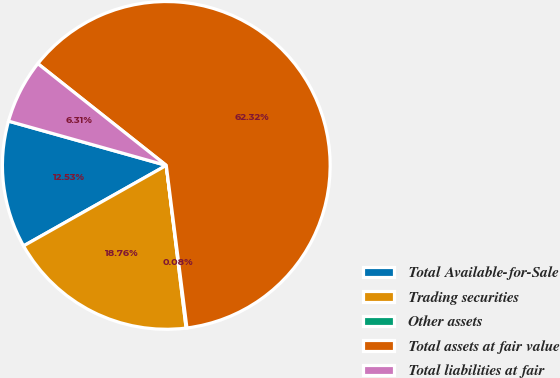<chart> <loc_0><loc_0><loc_500><loc_500><pie_chart><fcel>Total Available-for-Sale<fcel>Trading securities<fcel>Other assets<fcel>Total assets at fair value<fcel>Total liabilities at fair<nl><fcel>12.53%<fcel>18.76%<fcel>0.08%<fcel>62.33%<fcel>6.31%<nl></chart> 